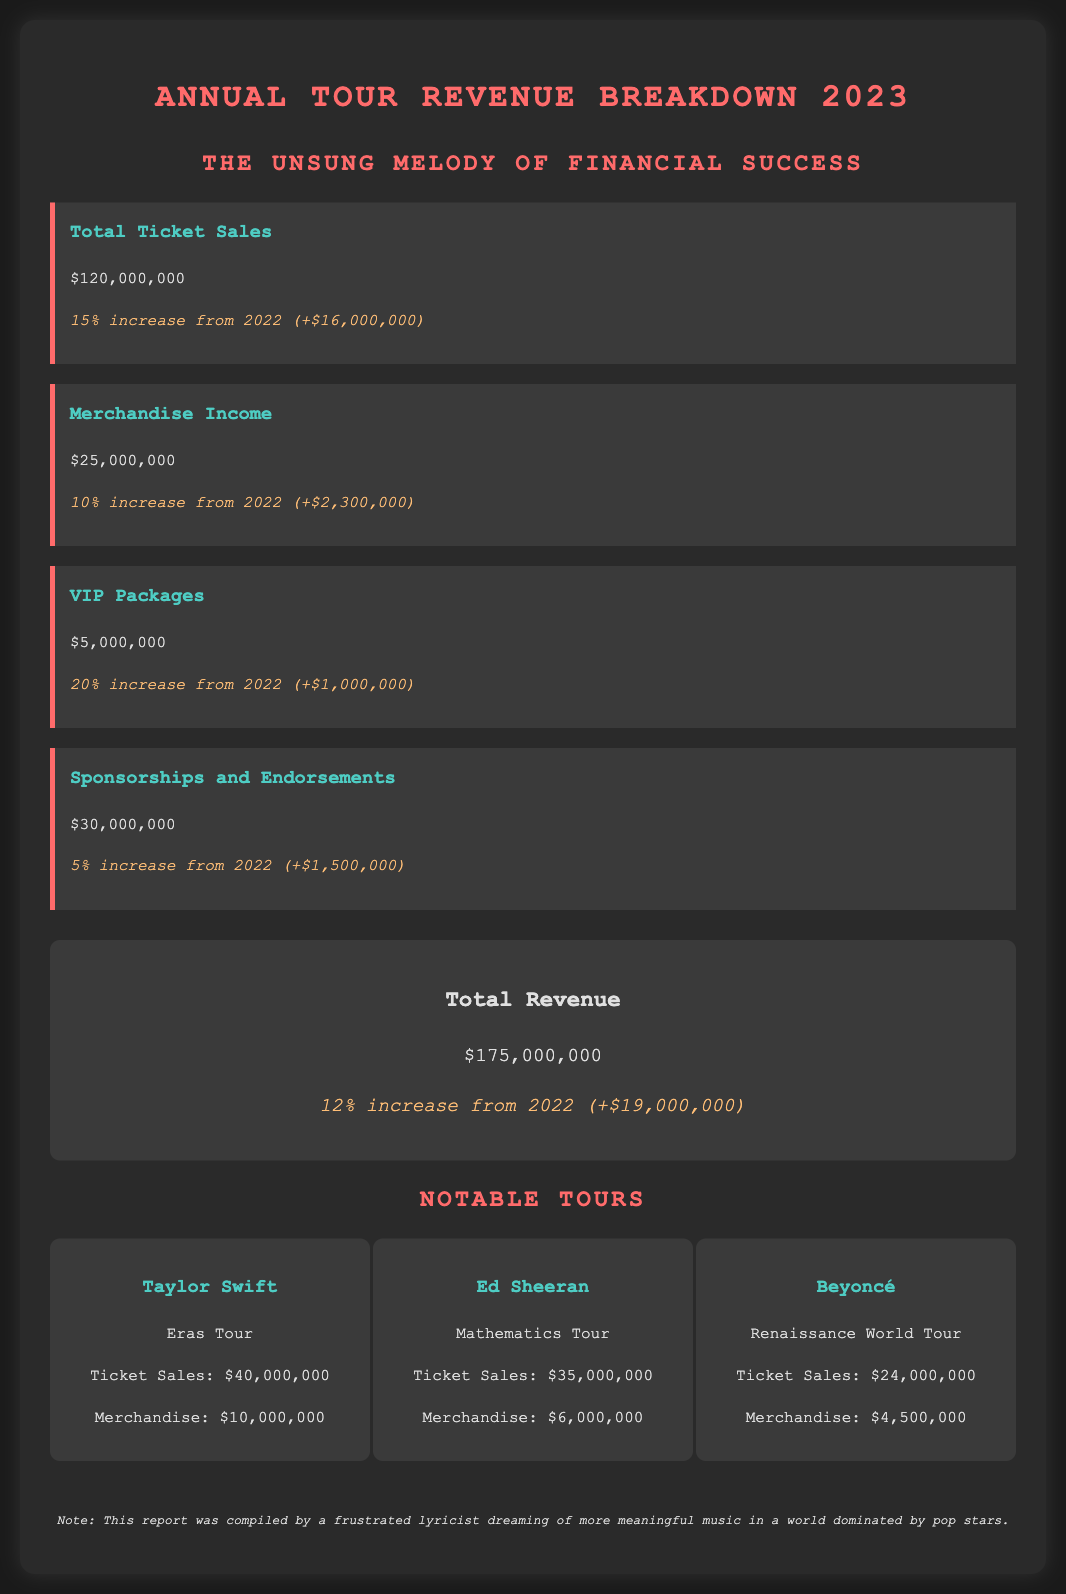What is the total ticket sales for 2023? The total ticket sales for 2023 is presented in the document and is $120,000,000.
Answer: $120,000,000 How much did merchandise income increase compared to 2022? The document states that merchandise income increased by 10% from 2022, amounting to an increase of $2,300,000.
Answer: $2,300,000 What was the revenue from VIP packages? VIP package revenue is specifically mentioned in the document, totalling $5,000,000.
Answer: $5,000,000 Which tour generated the highest ticket sales? The document lists notable tours and indicates that Taylor Swift's Eras Tour had the highest ticket sales at $40,000,000.
Answer: Taylor Swift What is the percentage increase in total revenue from 2022? The total revenue increase percentage from 2022 is provided in the document as 12%.
Answer: 12% How much did Ed Sheeran earn from merchandise? The document provides information on Ed Sheeran's merchandise earnings, which amount to $6,000,000.
Answer: $6,000,000 What is the total revenue for 2023? The total revenue figure for 2023 is summed up in the document as $175,000,000.
Answer: $175,000,000 What was the revenue from sponsorships and endorsements? The document clearly states that sponsorships and endorsements revenue is $30,000,000.
Answer: $30,000,000 What is the overall theme mentioned in the subtitle of the document? The subtitle indicates the theme of the report as “The Unsung Melody of Financial Success.”
Answer: The Unsung Melody of Financial Success 